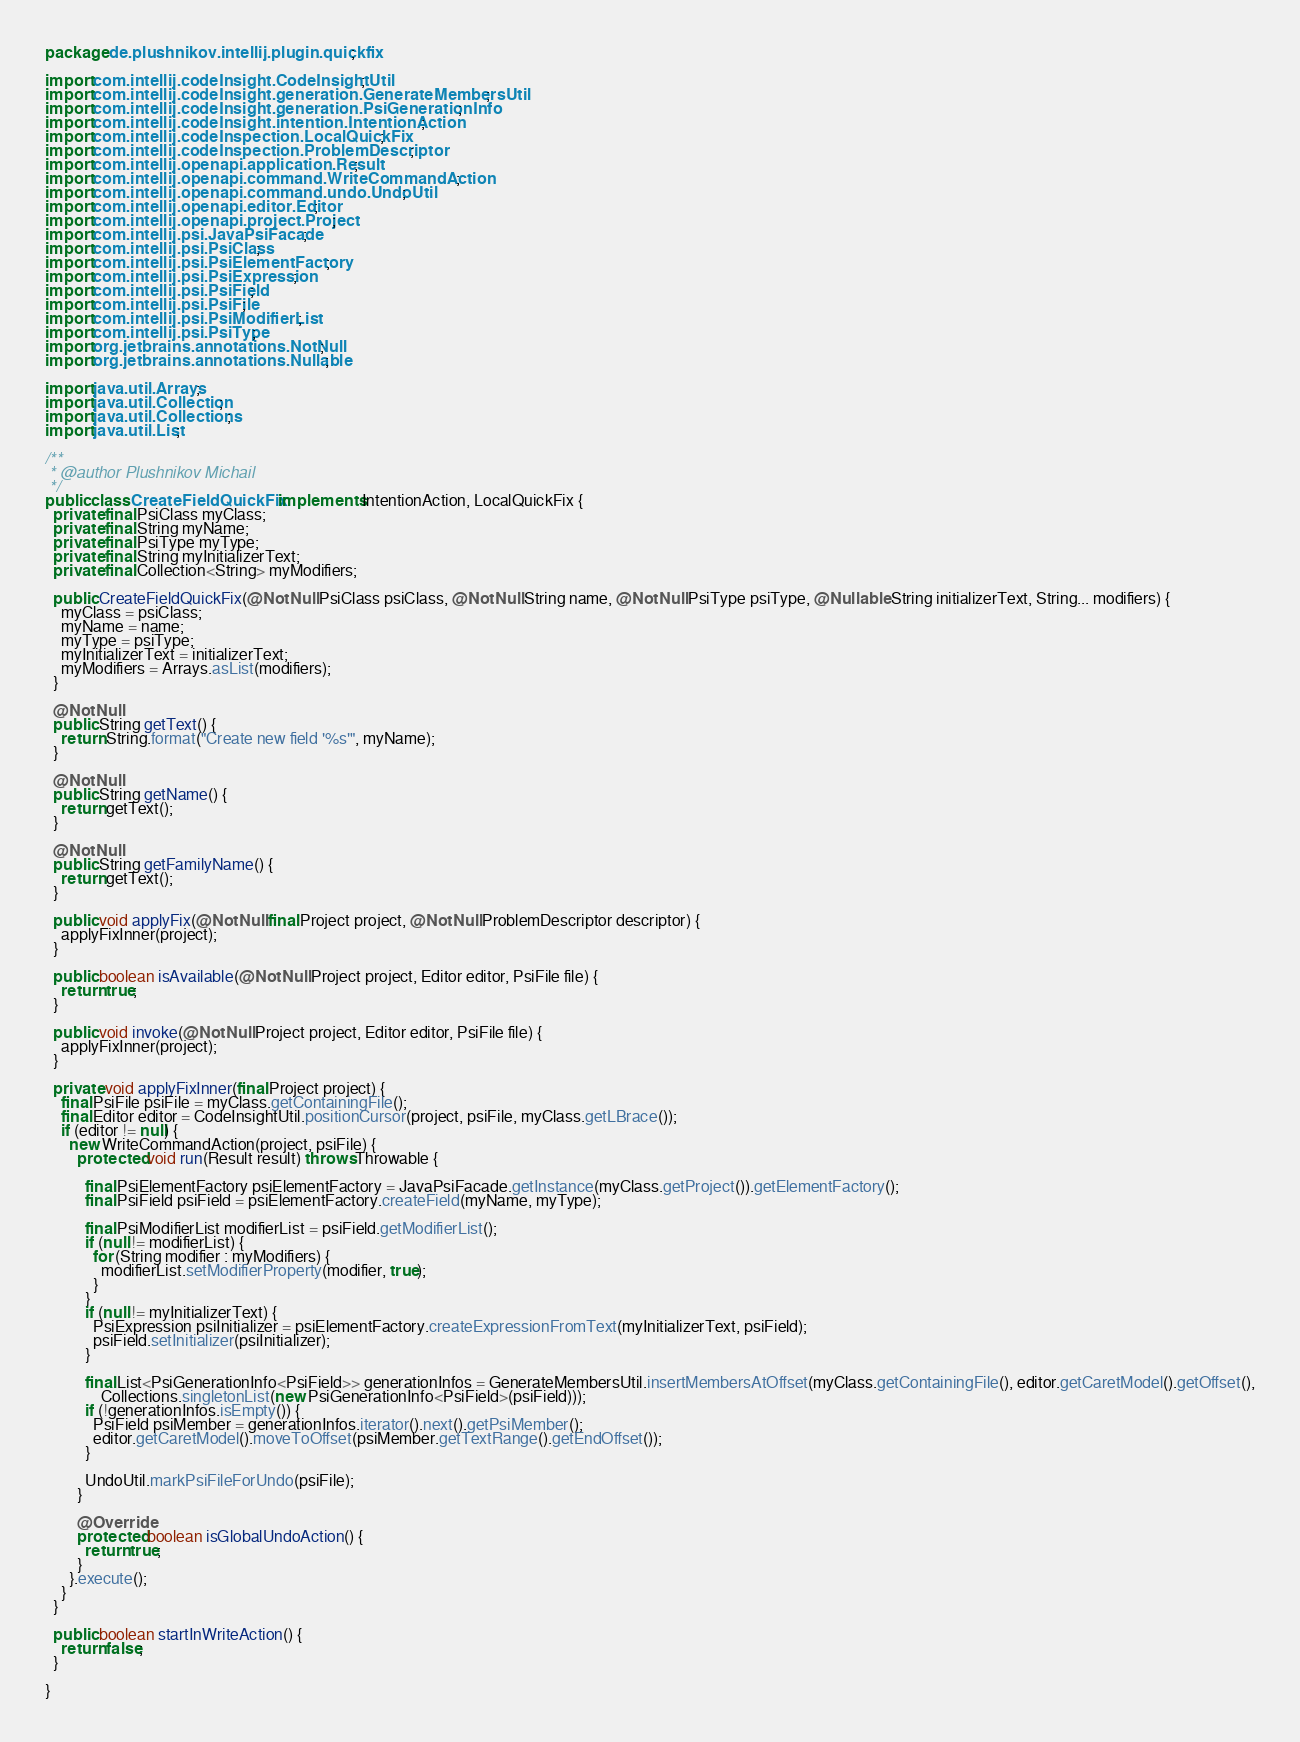Convert code to text. <code><loc_0><loc_0><loc_500><loc_500><_Java_>package de.plushnikov.intellij.plugin.quickfix;

import com.intellij.codeInsight.CodeInsightUtil;
import com.intellij.codeInsight.generation.GenerateMembersUtil;
import com.intellij.codeInsight.generation.PsiGenerationInfo;
import com.intellij.codeInsight.intention.IntentionAction;
import com.intellij.codeInspection.LocalQuickFix;
import com.intellij.codeInspection.ProblemDescriptor;
import com.intellij.openapi.application.Result;
import com.intellij.openapi.command.WriteCommandAction;
import com.intellij.openapi.command.undo.UndoUtil;
import com.intellij.openapi.editor.Editor;
import com.intellij.openapi.project.Project;
import com.intellij.psi.JavaPsiFacade;
import com.intellij.psi.PsiClass;
import com.intellij.psi.PsiElementFactory;
import com.intellij.psi.PsiExpression;
import com.intellij.psi.PsiField;
import com.intellij.psi.PsiFile;
import com.intellij.psi.PsiModifierList;
import com.intellij.psi.PsiType;
import org.jetbrains.annotations.NotNull;
import org.jetbrains.annotations.Nullable;

import java.util.Arrays;
import java.util.Collection;
import java.util.Collections;
import java.util.List;

/**
 * @author Plushnikov Michail
 */
public class CreateFieldQuickFix implements IntentionAction, LocalQuickFix {
  private final PsiClass myClass;
  private final String myName;
  private final PsiType myType;
  private final String myInitializerText;
  private final Collection<String> myModifiers;

  public CreateFieldQuickFix(@NotNull PsiClass psiClass, @NotNull String name, @NotNull PsiType psiType, @Nullable String initializerText, String... modifiers) {
    myClass = psiClass;
    myName = name;
    myType = psiType;
    myInitializerText = initializerText;
    myModifiers = Arrays.asList(modifiers);
  }

  @NotNull
  public String getText() {
    return String.format("Create new field '%s'", myName);
  }

  @NotNull
  public String getName() {
    return getText();
  }

  @NotNull
  public String getFamilyName() {
    return getText();
  }

  public void applyFix(@NotNull final Project project, @NotNull ProblemDescriptor descriptor) {
    applyFixInner(project);
  }

  public boolean isAvailable(@NotNull Project project, Editor editor, PsiFile file) {
    return true;
  }

  public void invoke(@NotNull Project project, Editor editor, PsiFile file) {
    applyFixInner(project);
  }

  private void applyFixInner(final Project project) {
    final PsiFile psiFile = myClass.getContainingFile();
    final Editor editor = CodeInsightUtil.positionCursor(project, psiFile, myClass.getLBrace());
    if (editor != null) {
      new WriteCommandAction(project, psiFile) {
        protected void run(Result result) throws Throwable {

          final PsiElementFactory psiElementFactory = JavaPsiFacade.getInstance(myClass.getProject()).getElementFactory();
          final PsiField psiField = psiElementFactory.createField(myName, myType);

          final PsiModifierList modifierList = psiField.getModifierList();
          if (null != modifierList) {
            for (String modifier : myModifiers) {
              modifierList.setModifierProperty(modifier, true);
            }
          }
          if (null != myInitializerText) {
            PsiExpression psiInitializer = psiElementFactory.createExpressionFromText(myInitializerText, psiField);
            psiField.setInitializer(psiInitializer);
          }

          final List<PsiGenerationInfo<PsiField>> generationInfos = GenerateMembersUtil.insertMembersAtOffset(myClass.getContainingFile(), editor.getCaretModel().getOffset(),
              Collections.singletonList(new PsiGenerationInfo<PsiField>(psiField)));
          if (!generationInfos.isEmpty()) {
            PsiField psiMember = generationInfos.iterator().next().getPsiMember();
            editor.getCaretModel().moveToOffset(psiMember.getTextRange().getEndOffset());
          }

          UndoUtil.markPsiFileForUndo(psiFile);
        }

        @Override
        protected boolean isGlobalUndoAction() {
          return true;
        }
      }.execute();
    }
  }

  public boolean startInWriteAction() {
    return false;
  }

}
</code> 